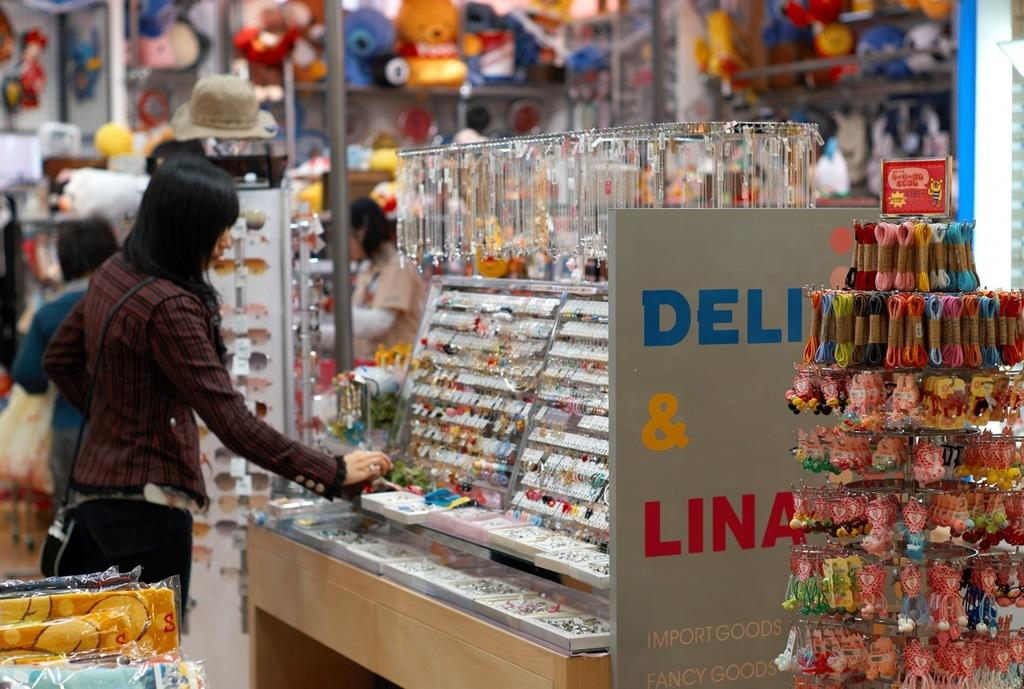What type of location is depicted in the image? There is a market in the image. What can be found in the market? There are various items placed in the market. Are there any people present in the image? Yes, there are people walking around in the market. What type of bait is being used to catch fish in the image? There is no fishing or bait present in the image; it depicts a market with various items and people walking around. 